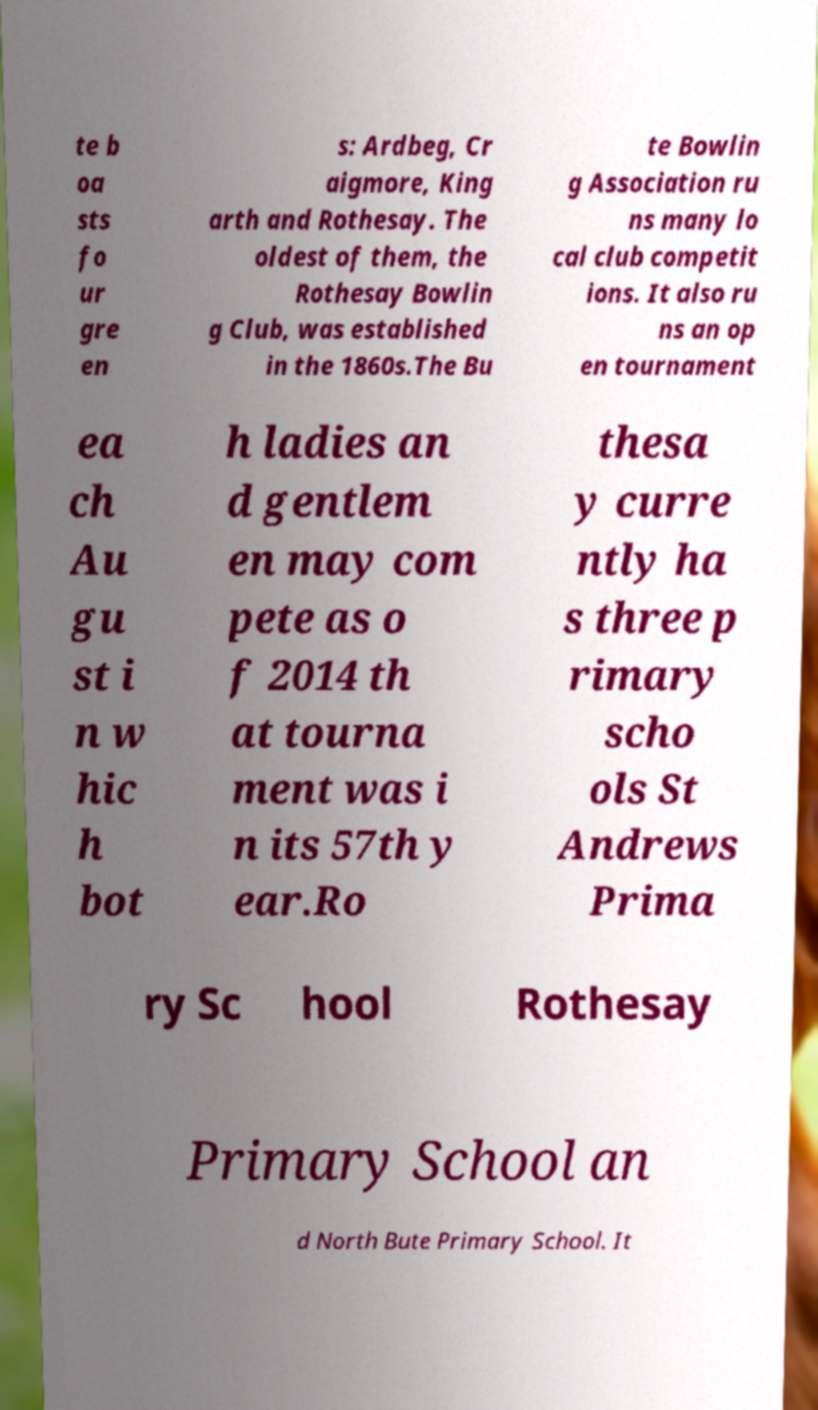What messages or text are displayed in this image? I need them in a readable, typed format. te b oa sts fo ur gre en s: Ardbeg, Cr aigmore, King arth and Rothesay. The oldest of them, the Rothesay Bowlin g Club, was established in the 1860s.The Bu te Bowlin g Association ru ns many lo cal club competit ions. It also ru ns an op en tournament ea ch Au gu st i n w hic h bot h ladies an d gentlem en may com pete as o f 2014 th at tourna ment was i n its 57th y ear.Ro thesa y curre ntly ha s three p rimary scho ols St Andrews Prima ry Sc hool Rothesay Primary School an d North Bute Primary School. It 